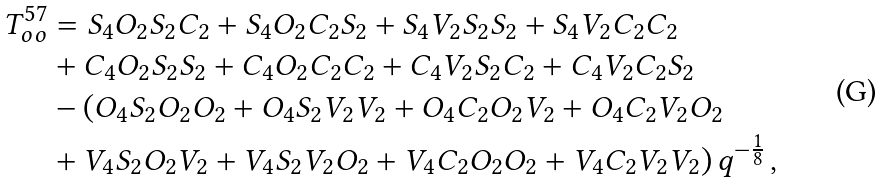Convert formula to latex. <formula><loc_0><loc_0><loc_500><loc_500>T ^ { 5 7 } _ { o o } & = S _ { 4 } O _ { 2 } S _ { 2 } C _ { 2 } + S _ { 4 } O _ { 2 } C _ { 2 } S _ { 2 } + S _ { 4 } V _ { 2 } S _ { 2 } S _ { 2 } + S _ { 4 } V _ { 2 } C _ { 2 } C _ { 2 } \\ & + C _ { 4 } O _ { 2 } S _ { 2 } S _ { 2 } + C _ { 4 } O _ { 2 } C _ { 2 } C _ { 2 } + C _ { 4 } V _ { 2 } S _ { 2 } C _ { 2 } + C _ { 4 } V _ { 2 } C _ { 2 } S _ { 2 } \\ & - ( O _ { 4 } S _ { 2 } O _ { 2 } O _ { 2 } + O _ { 4 } S _ { 2 } V _ { 2 } V _ { 2 } + O _ { 4 } C _ { 2 } O _ { 2 } V _ { 2 } + O _ { 4 } C _ { 2 } V _ { 2 } O _ { 2 } \\ & + V _ { 4 } S _ { 2 } O _ { 2 } V _ { 2 } + V _ { 4 } S _ { 2 } V _ { 2 } O _ { 2 } + V _ { 4 } C _ { 2 } O _ { 2 } O _ { 2 } + V _ { 4 } C _ { 2 } V _ { 2 } V _ { 2 } ) \, q ^ { - \frac { 1 } { 8 } } \, , \\</formula> 